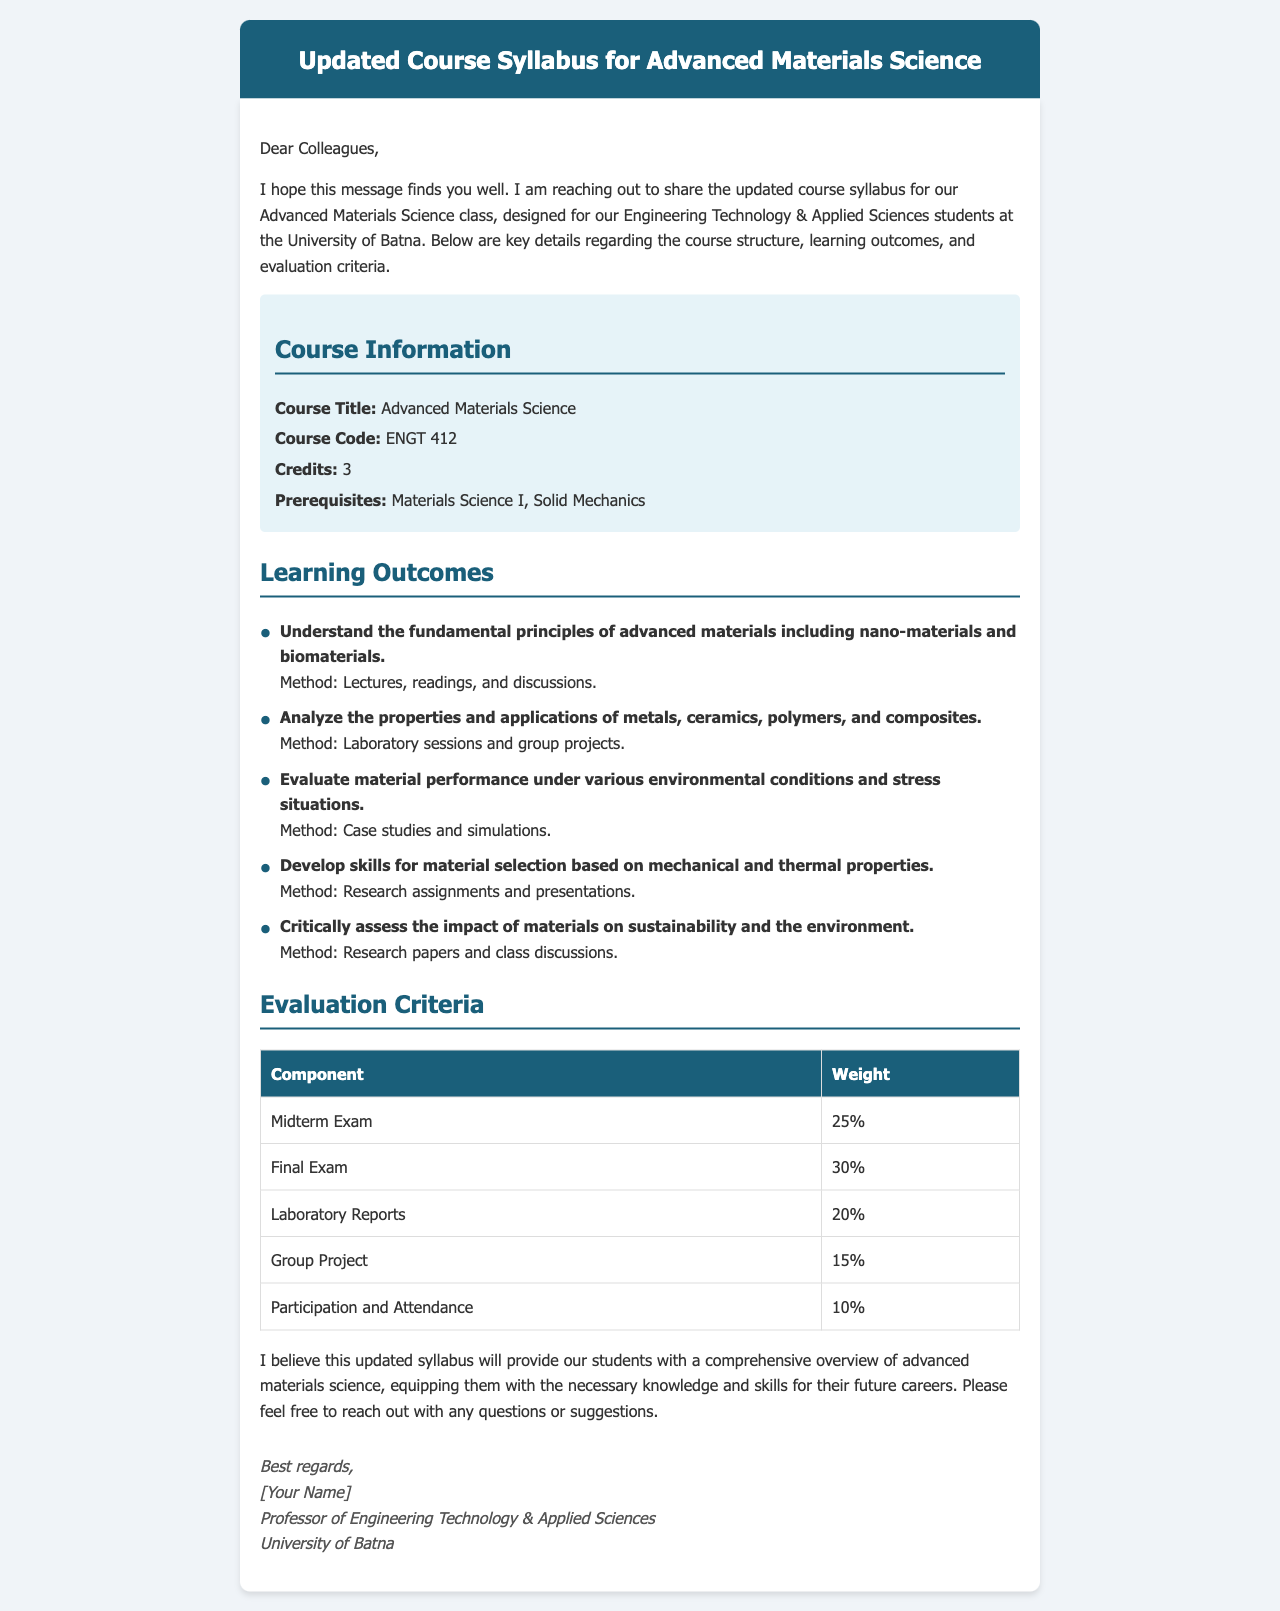What is the course title? The course title is explicitly mentioned in the course information section.
Answer: Advanced Materials Science What is the course code? The course code is provided under the course information section.
Answer: ENGT 412 How many credits is the course worth? The number of credits is stated in the course information section.
Answer: 3 What is the weight of the final exam? The weight of the final exam is listed in the evaluation criteria table.
Answer: 30% What is one method used to assess the impact of materials on sustainability? The document lists specific methods for each learning outcome, including research papers.
Answer: Research papers What is the total weight of laboratory reports and group project combined? The weight of laboratory reports and group project needs to be added from the evaluation criteria.
Answer: 35% What prerequisites are required for this course? Prerequisites are specified in the course information section of the document.
Answer: Materials Science I, Solid Mechanics How many learning outcomes are listed in the syllabus? The number of learning outcomes is determined by counting the items in the list provided.
Answer: 5 What is stated as the method for analyzing properties and applications? The method for this learning outcome is clearly described in the document.
Answer: Laboratory sessions and group projects 